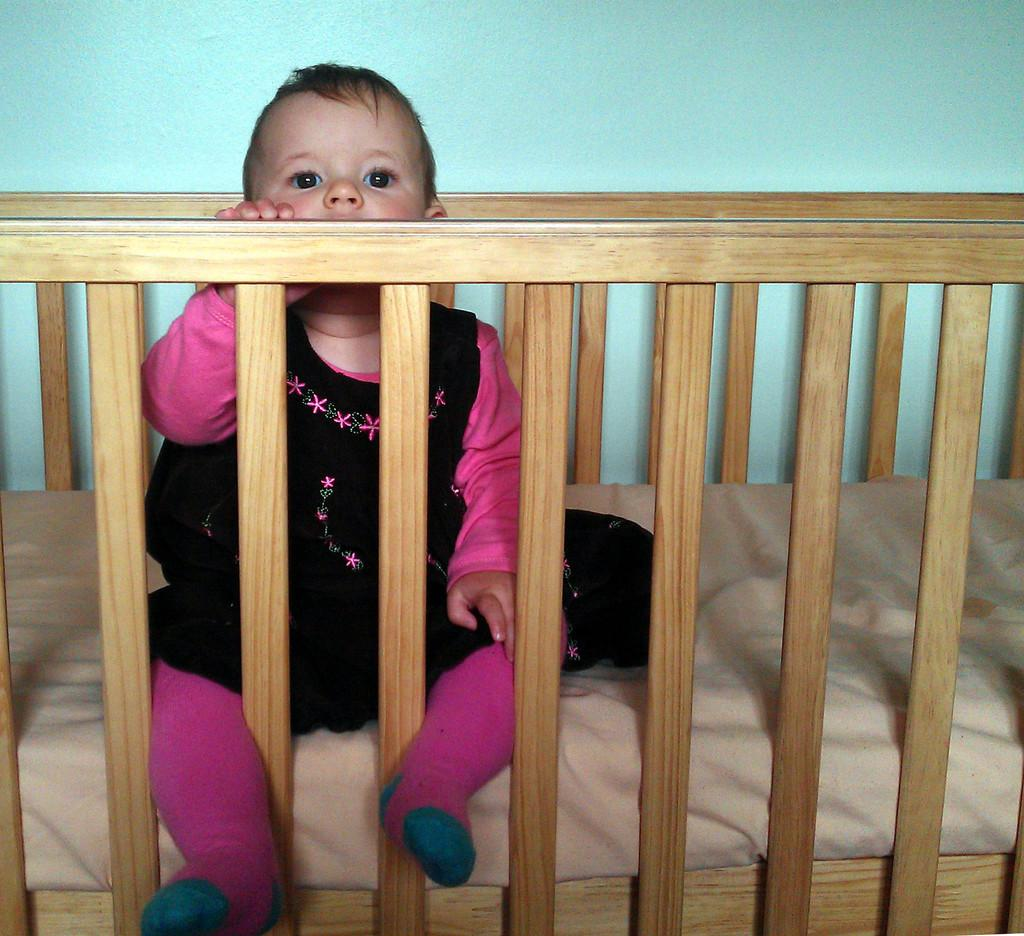What is the main subject of the image? There is a baby in the image. Where is the baby located? The baby is sitting on a bed. What is the baby doing with their legs? The baby's legs are through the railing. What can be seen in the background of the image? There is a wall in the background of the image. What type of lock is securing the baby's minute order in the image? There is no lock or order present in the image; it features a baby sitting on a bed with their legs through the railing. 